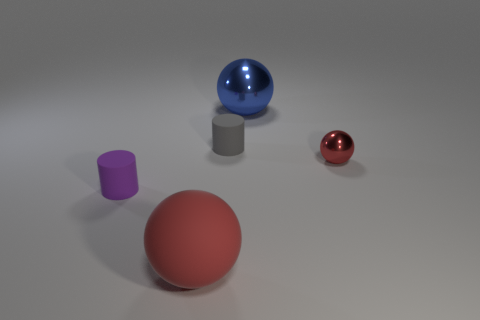Do the large rubber thing and the small sphere have the same color?
Keep it short and to the point. Yes. The blue thing is what size?
Offer a terse response. Large. What number of blue metallic things are in front of the tiny thing that is to the left of the red sphere on the left side of the blue metallic thing?
Your response must be concise. 0. The metal object to the left of the red thing right of the large metal sphere is what shape?
Your response must be concise. Sphere. What is the size of the gray matte object that is the same shape as the purple rubber object?
Keep it short and to the point. Small. What is the color of the small matte cylinder that is behind the small purple matte thing?
Provide a short and direct response. Gray. What is the material of the cylinder on the left side of the large object that is on the left side of the large object that is behind the tiny gray rubber thing?
Provide a succinct answer. Rubber. There is a cylinder behind the small purple cylinder in front of the blue sphere; what is its size?
Provide a succinct answer. Small. What is the color of the other large metal object that is the same shape as the red shiny thing?
Provide a succinct answer. Blue. What number of other tiny spheres have the same color as the tiny ball?
Ensure brevity in your answer.  0. 